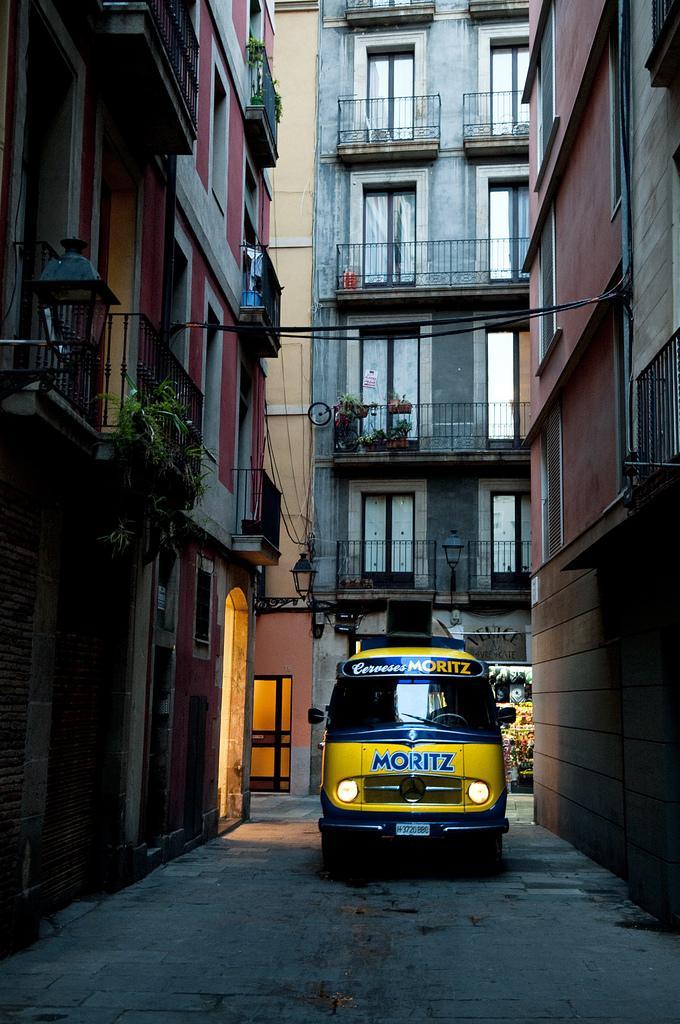In one or two sentences, can you explain what this image depicts? In this image there is a road. There are vehicles. There are buildings all around. 